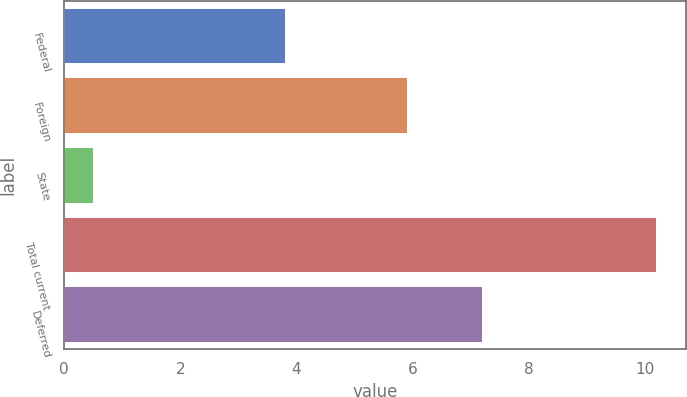<chart> <loc_0><loc_0><loc_500><loc_500><bar_chart><fcel>Federal<fcel>Foreign<fcel>State<fcel>Total current<fcel>Deferred<nl><fcel>3.8<fcel>5.9<fcel>0.5<fcel>10.2<fcel>7.2<nl></chart> 